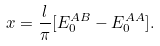Convert formula to latex. <formula><loc_0><loc_0><loc_500><loc_500>x = \frac { l } { \pi } [ E ^ { A B } _ { 0 } - E ^ { A A } _ { 0 } ] .</formula> 